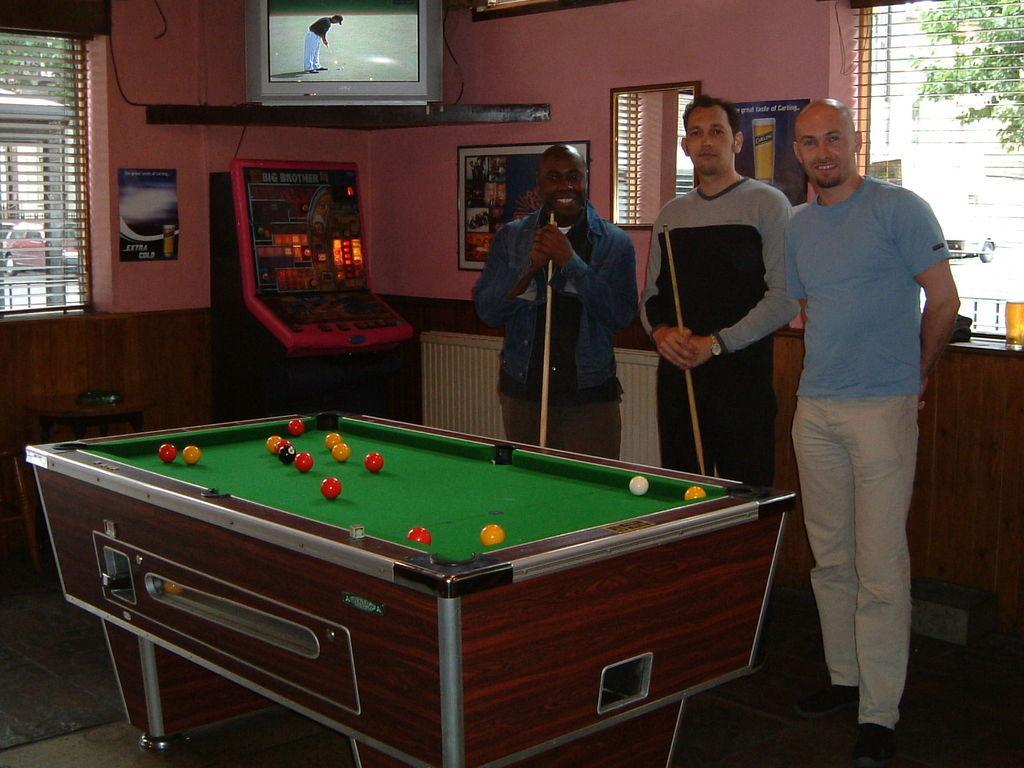In one or two sentences, can you explain what this image depicts? In the image we can see there are men who are standing and the men are holding sticks in their hand and there is a billiard board in which there are balls kept and on the top there is a tv. 